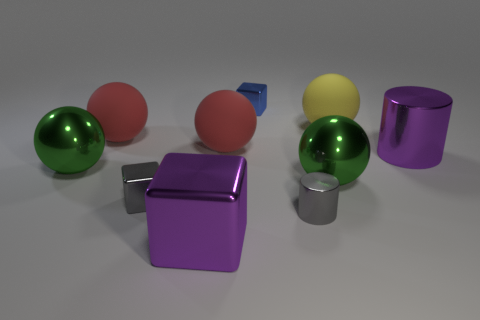Subtract all yellow balls. How many balls are left? 4 Subtract all yellow spheres. How many spheres are left? 4 Subtract all yellow balls. Subtract all purple cylinders. How many balls are left? 4 Subtract all blocks. How many objects are left? 7 Add 1 small cylinders. How many small cylinders exist? 2 Subtract 0 yellow cylinders. How many objects are left? 10 Subtract all small gray cylinders. Subtract all large green metallic objects. How many objects are left? 7 Add 3 gray blocks. How many gray blocks are left? 4 